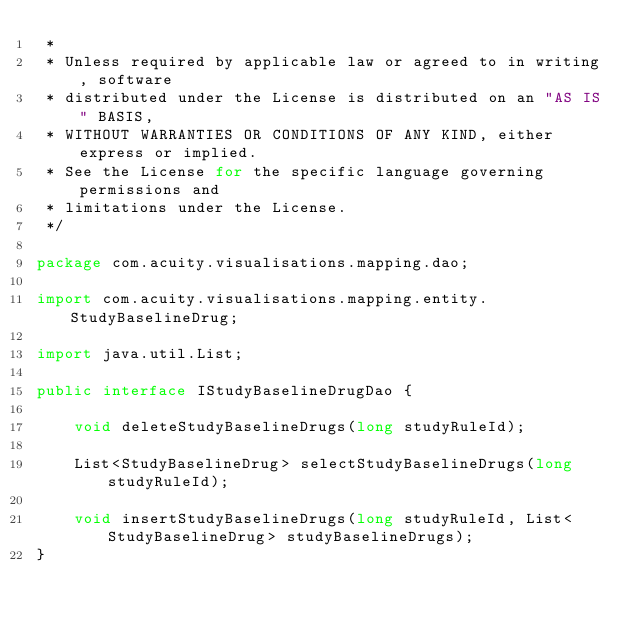<code> <loc_0><loc_0><loc_500><loc_500><_Java_> *
 * Unless required by applicable law or agreed to in writing, software
 * distributed under the License is distributed on an "AS IS" BASIS,
 * WITHOUT WARRANTIES OR CONDITIONS OF ANY KIND, either express or implied.
 * See the License for the specific language governing permissions and
 * limitations under the License.
 */

package com.acuity.visualisations.mapping.dao;

import com.acuity.visualisations.mapping.entity.StudyBaselineDrug;

import java.util.List;

public interface IStudyBaselineDrugDao {

    void deleteStudyBaselineDrugs(long studyRuleId);

    List<StudyBaselineDrug> selectStudyBaselineDrugs(long studyRuleId);

    void insertStudyBaselineDrugs(long studyRuleId, List<StudyBaselineDrug> studyBaselineDrugs);
}
</code> 